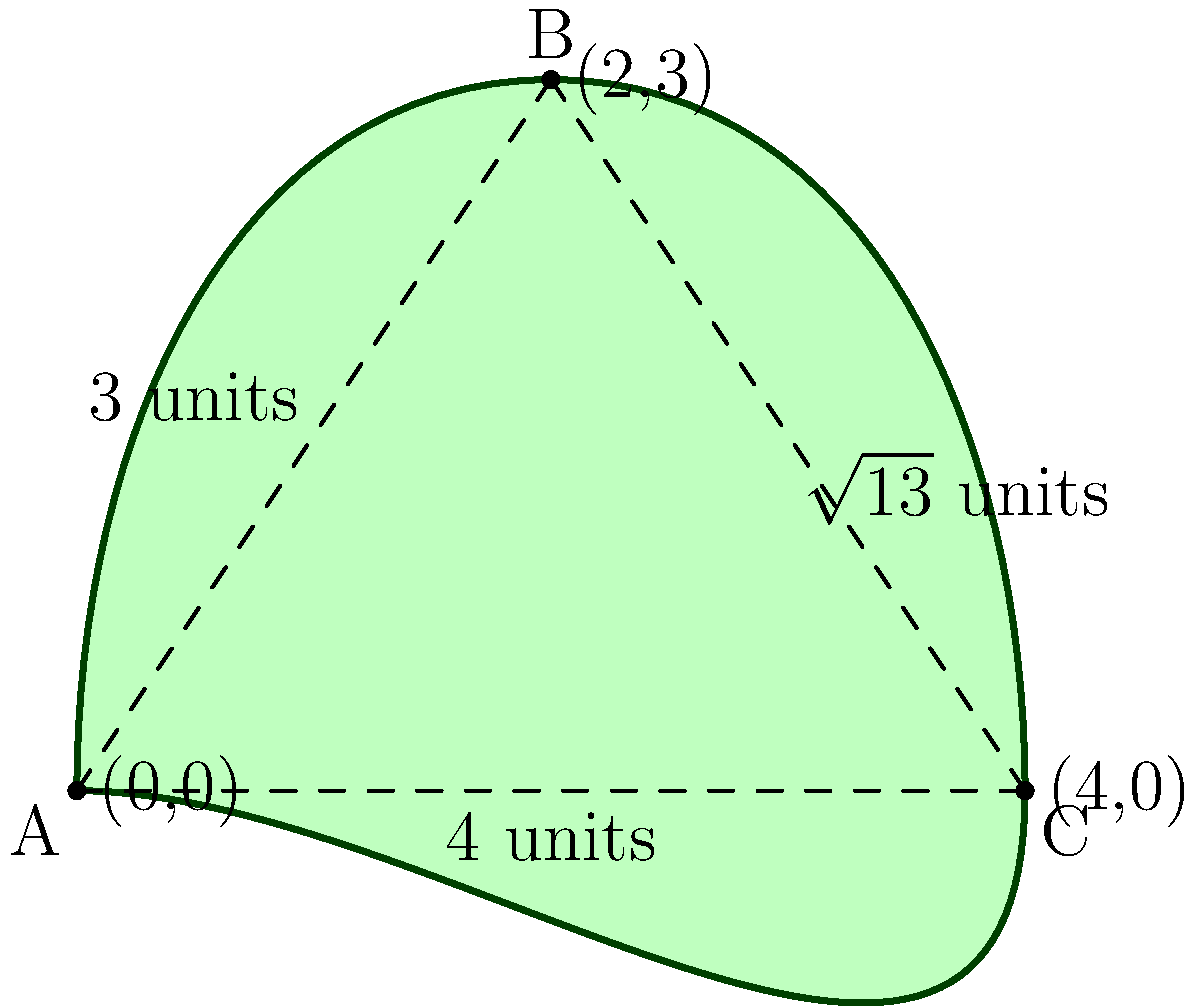Roscoe Park, a hidden gem in our neighborhood, has an irregular shape with curved boundaries. The park can be approximated by a triangle ABC with a curved perimeter, as shown in the diagram. If the straight-line distances between the points are: AB = 3 units, BC = $\sqrt{13}$ units, and AC = 4 units, estimate the area of Roscoe Park using the triangular approximation. To estimate the area of Roscoe Park using the triangular approximation, we'll use Heron's formula. Let's approach this step-by-step:

1) First, recall Heron's formula for the area of a triangle:
   $A = \sqrt{s(s-a)(s-b)(s-c)}$
   where $s$ is the semi-perimeter, and $a$, $b$, and $c$ are the side lengths.

2) We have:
   $a = 3$
   $b = \sqrt{13}$
   $c = 4$

3) Calculate the semi-perimeter $s$:
   $s = \frac{a + b + c}{2} = \frac{3 + \sqrt{13} + 4}{2} = \frac{7 + \sqrt{13}}{2}$

4) Now, let's substitute these values into Heron's formula:
   $A = \sqrt{\frac{7 + \sqrt{13}}{2} \cdot (\frac{7 + \sqrt{13}}{2} - 3) \cdot (\frac{7 + \sqrt{13}}{2} - \sqrt{13}) \cdot (\frac{7 + \sqrt{13}}{2} - 4)}$

5) Simplify:
   $A = \sqrt{\frac{7 + \sqrt{13}}{2} \cdot \frac{1 + \sqrt{13}}{2} \cdot \frac{7 - \sqrt{13}}{2} \cdot \frac{-1 + \sqrt{13}}{2}}$

6) Multiply terms under the square root:
   $A = \sqrt{\frac{(7 + \sqrt{13})(1 + \sqrt{13})(7 - \sqrt{13})(-1 + \sqrt{13})}{16}}$

7) Simplify further:
   $A = \frac{\sqrt{(50 - 13)(50 - 13)}}{4} = \frac{\sqrt{37 \cdot 37}}{4} = \frac{37}{4}$

Therefore, the estimated area of Roscoe Park using the triangular approximation is $\frac{37}{4}$ square units.
Answer: $\frac{37}{4}$ square units 